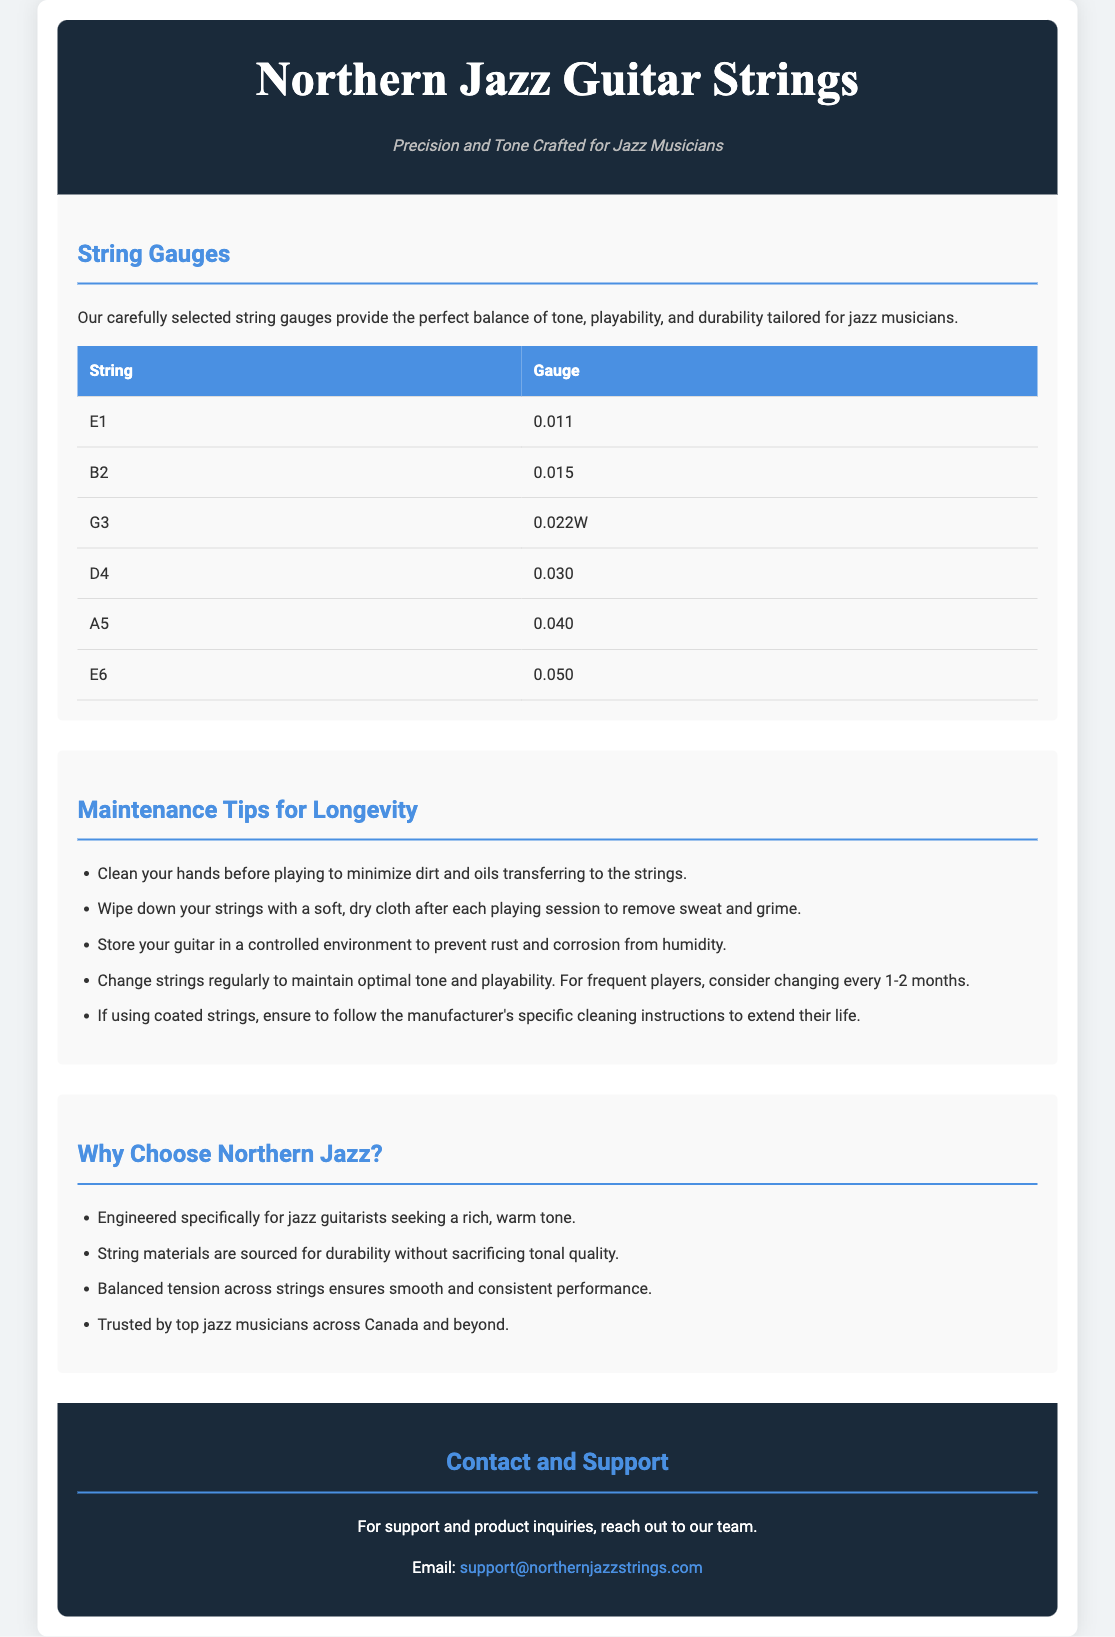what is the gauge of the E1 string? The gauge for the E1 string is found in the table under "String Gauges."
Answer: 0.011 what is one maintenance tip for guitar strings? The maintenance tips are listed in the section titled "Maintenance Tips for Longevity."
Answer: Clean your hands before playing how many strings are listed in the string gauge table? The number of strings can be counted in the table under "String Gauges."
Answer: 6 what is the recommended frequency for changing strings for frequent players? This information is stated in the "Maintenance Tips for Longevity" section, giving a specific recommendation based on play frequency.
Answer: Every 1-2 months which company provides these guitar strings? The brand name is prominently displayed at the top of the document.
Answer: Northern Jazz what gauge is the A5 string? The gauge is provided in the string gauge table.
Answer: 0.040 why are these strings specifically engineered for jazz musicians? The document states reasons in the section titled "Why Choose Northern Jazz?" focusing on tone quality.
Answer: For rich, warm tone how should one store their guitar to prevent rust? The storage instructions can be found in the maintenance tips section of the document.
Answer: In a controlled environment 